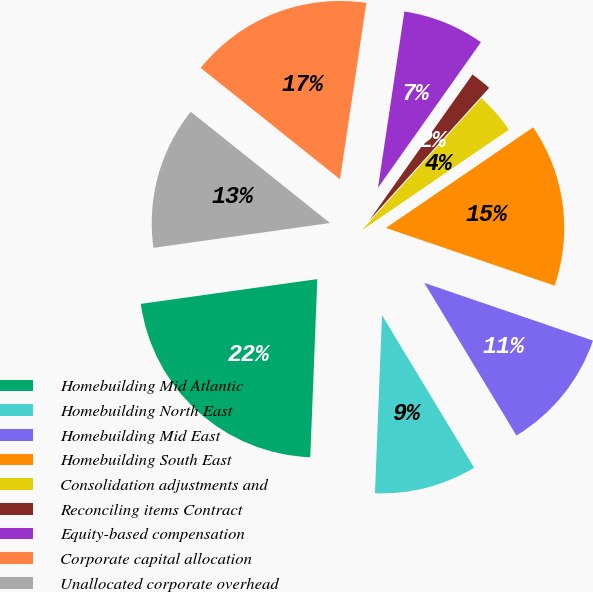Convert chart to OTSL. <chart><loc_0><loc_0><loc_500><loc_500><pie_chart><fcel>Homebuilding Mid Atlantic<fcel>Homebuilding North East<fcel>Homebuilding Mid East<fcel>Homebuilding South East<fcel>Consolidation adjustments and<fcel>Reconciling items Contract<fcel>Equity-based compensation<fcel>Corporate capital allocation<fcel>Unallocated corporate overhead<nl><fcel>22.15%<fcel>9.27%<fcel>11.11%<fcel>14.79%<fcel>3.75%<fcel>1.91%<fcel>7.43%<fcel>16.63%<fcel>12.95%<nl></chart> 